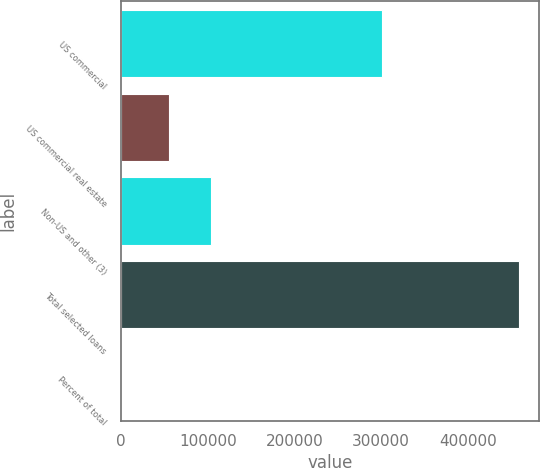Convert chart to OTSL. <chart><loc_0><loc_0><loc_500><loc_500><bar_chart><fcel>US commercial<fcel>US commercial real estate<fcel>Non-US and other (3)<fcel>Total selected loans<fcel>Percent of total<nl><fcel>301112<fcel>54761<fcel>103484<fcel>459357<fcel>100<nl></chart> 